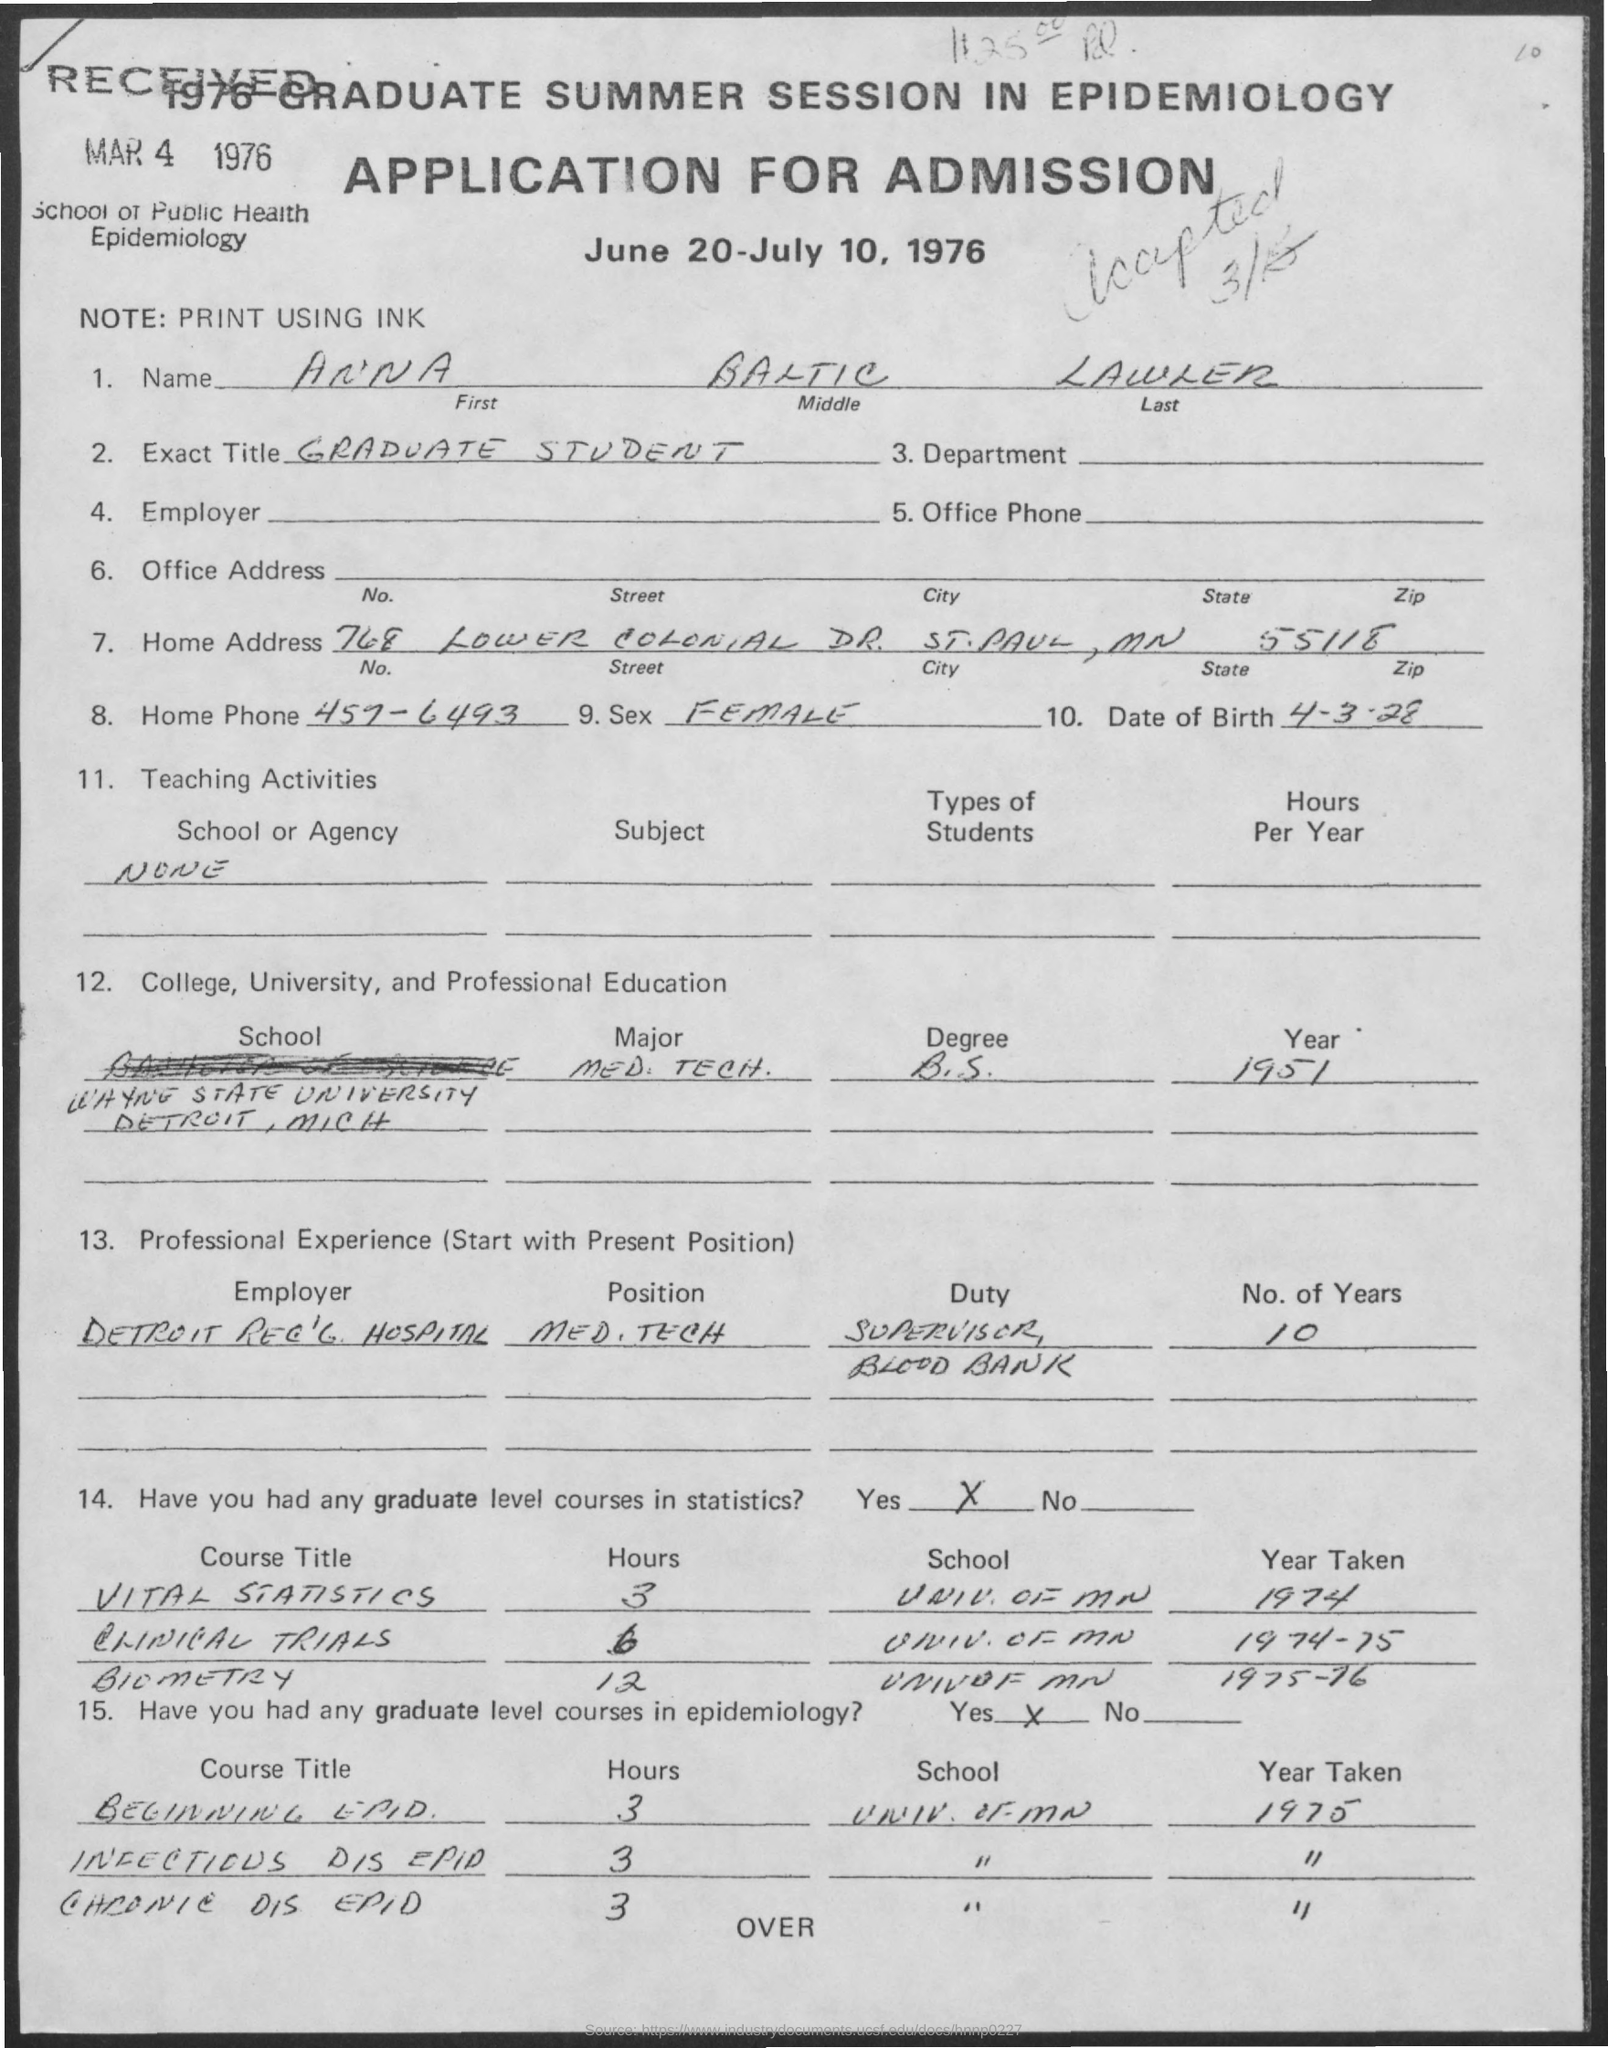What is the date for the application for admission ?
Give a very brief answer. June 20-july 10 , 1976. What is the name mentioned ?
Offer a terse response. Anna Baltic Lawler. What is the exact title?
Provide a succinct answer. Graduate Student. What is the home phone number ?
Provide a short and direct response. 457-6493. What is the zip code mentioned in the address
Your answer should be compact. 55118. What is the date of birth ?
Provide a short and direct response. 4-3-28. How many years of professional experience he has ?
Keep it short and to the point. 10. In which year he completed his degree ?
Offer a terse response. 1951. 